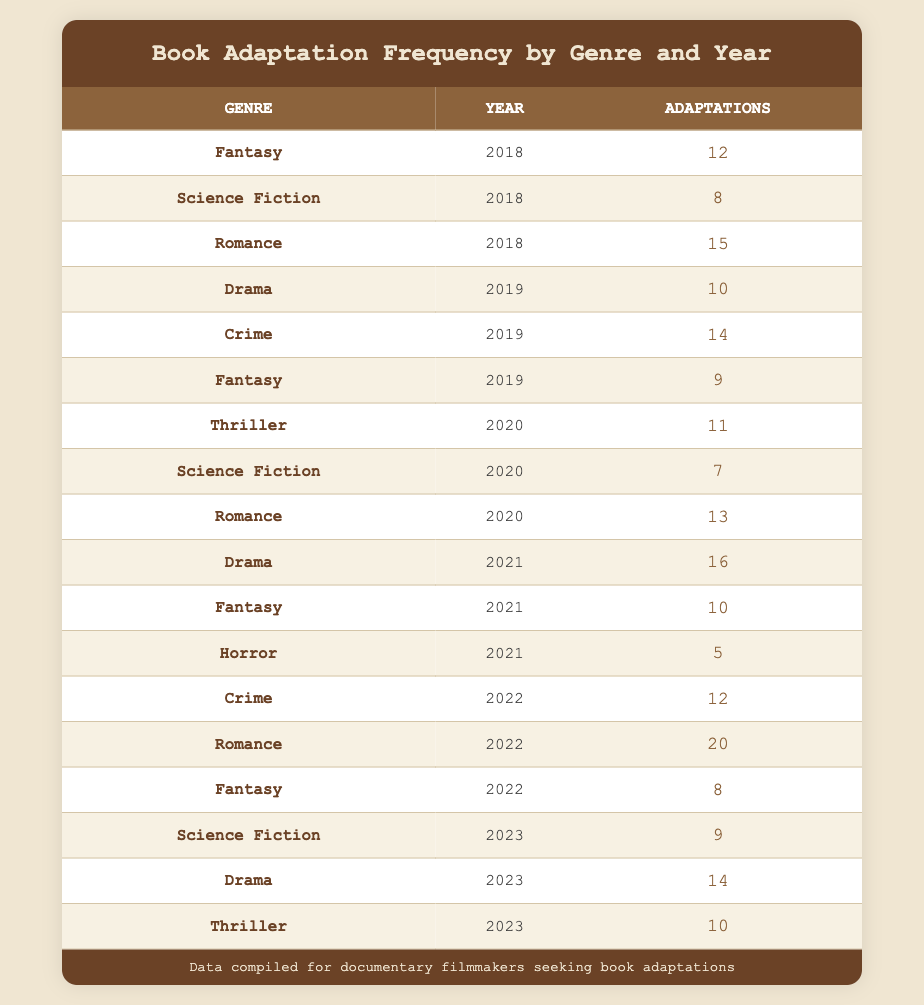What genre had the highest number of adaptations in 2018? From the table, by comparing the "adaptations" column for the year 2018, we can see that Romance has the highest value with 15 adaptations, while Fantasy has 12 and Science Fiction has 8 adaptations.
Answer: Romance How many adaptations of Drama were made in the year 2022? Referring to the table, there is only one entry for Drama in the year 2022, which shows 12 adaptations. Thus, the answer is directly obtained from that entry.
Answer: 12 What is the total number of Fantasy adaptations from 2018 to 2022? We need to aggregate the adaptations for Fantasy across the years. The values are: 12 (2018) + 9 (2019) + 10 (2021) + 8 (2022), which sums up to 39.
Answer: 39 Did the number of adaptations for Science Fiction increase from 2018 to 2023? Looking at the adaptations for Science Fiction from each year: 8 in 2018, 7 in 2020, and 9 in 2023. The values show a decrease from 2018 to 2020, and then an increase from 2020 to 2023 noted as follows: 8 > 7 < 9. Thus, the overall trend is not steadily increasing.
Answer: No Which genre had the least adaptations in 2021? By examining the adaptations for each genre in 2021, we find that Horror had the least with 5 adaptations, compared to Fantasy (10) and Drama (16).
Answer: Horror What was the average number of adaptations for the genre Romance across all years shown? To find the average for Romance, we look at the counts: 15 (2018) + 13 (2020) + 16 (2021) + 20 (2022) = 64. There are 4 data points, so we divide 64 by 4, giving us an average of 16.
Answer: 16 Is it true that there were more adaptations of Crime than Fantasy in 2019? For 2019, the Crime adaptations are 14, while Fantasy had 9. Since 14 is greater than 9, this statement is true.
Answer: Yes What is the difference in adaptations between the genre with the most adaptations in 2021 and the genre with the most adaptations in 2022? In 2021, the genre with the most adaptations was Drama with 16, and in 2022, the genre with the most adaptations was Romance with 20. Calculating the difference: 20 - 16 = 4.
Answer: 4 